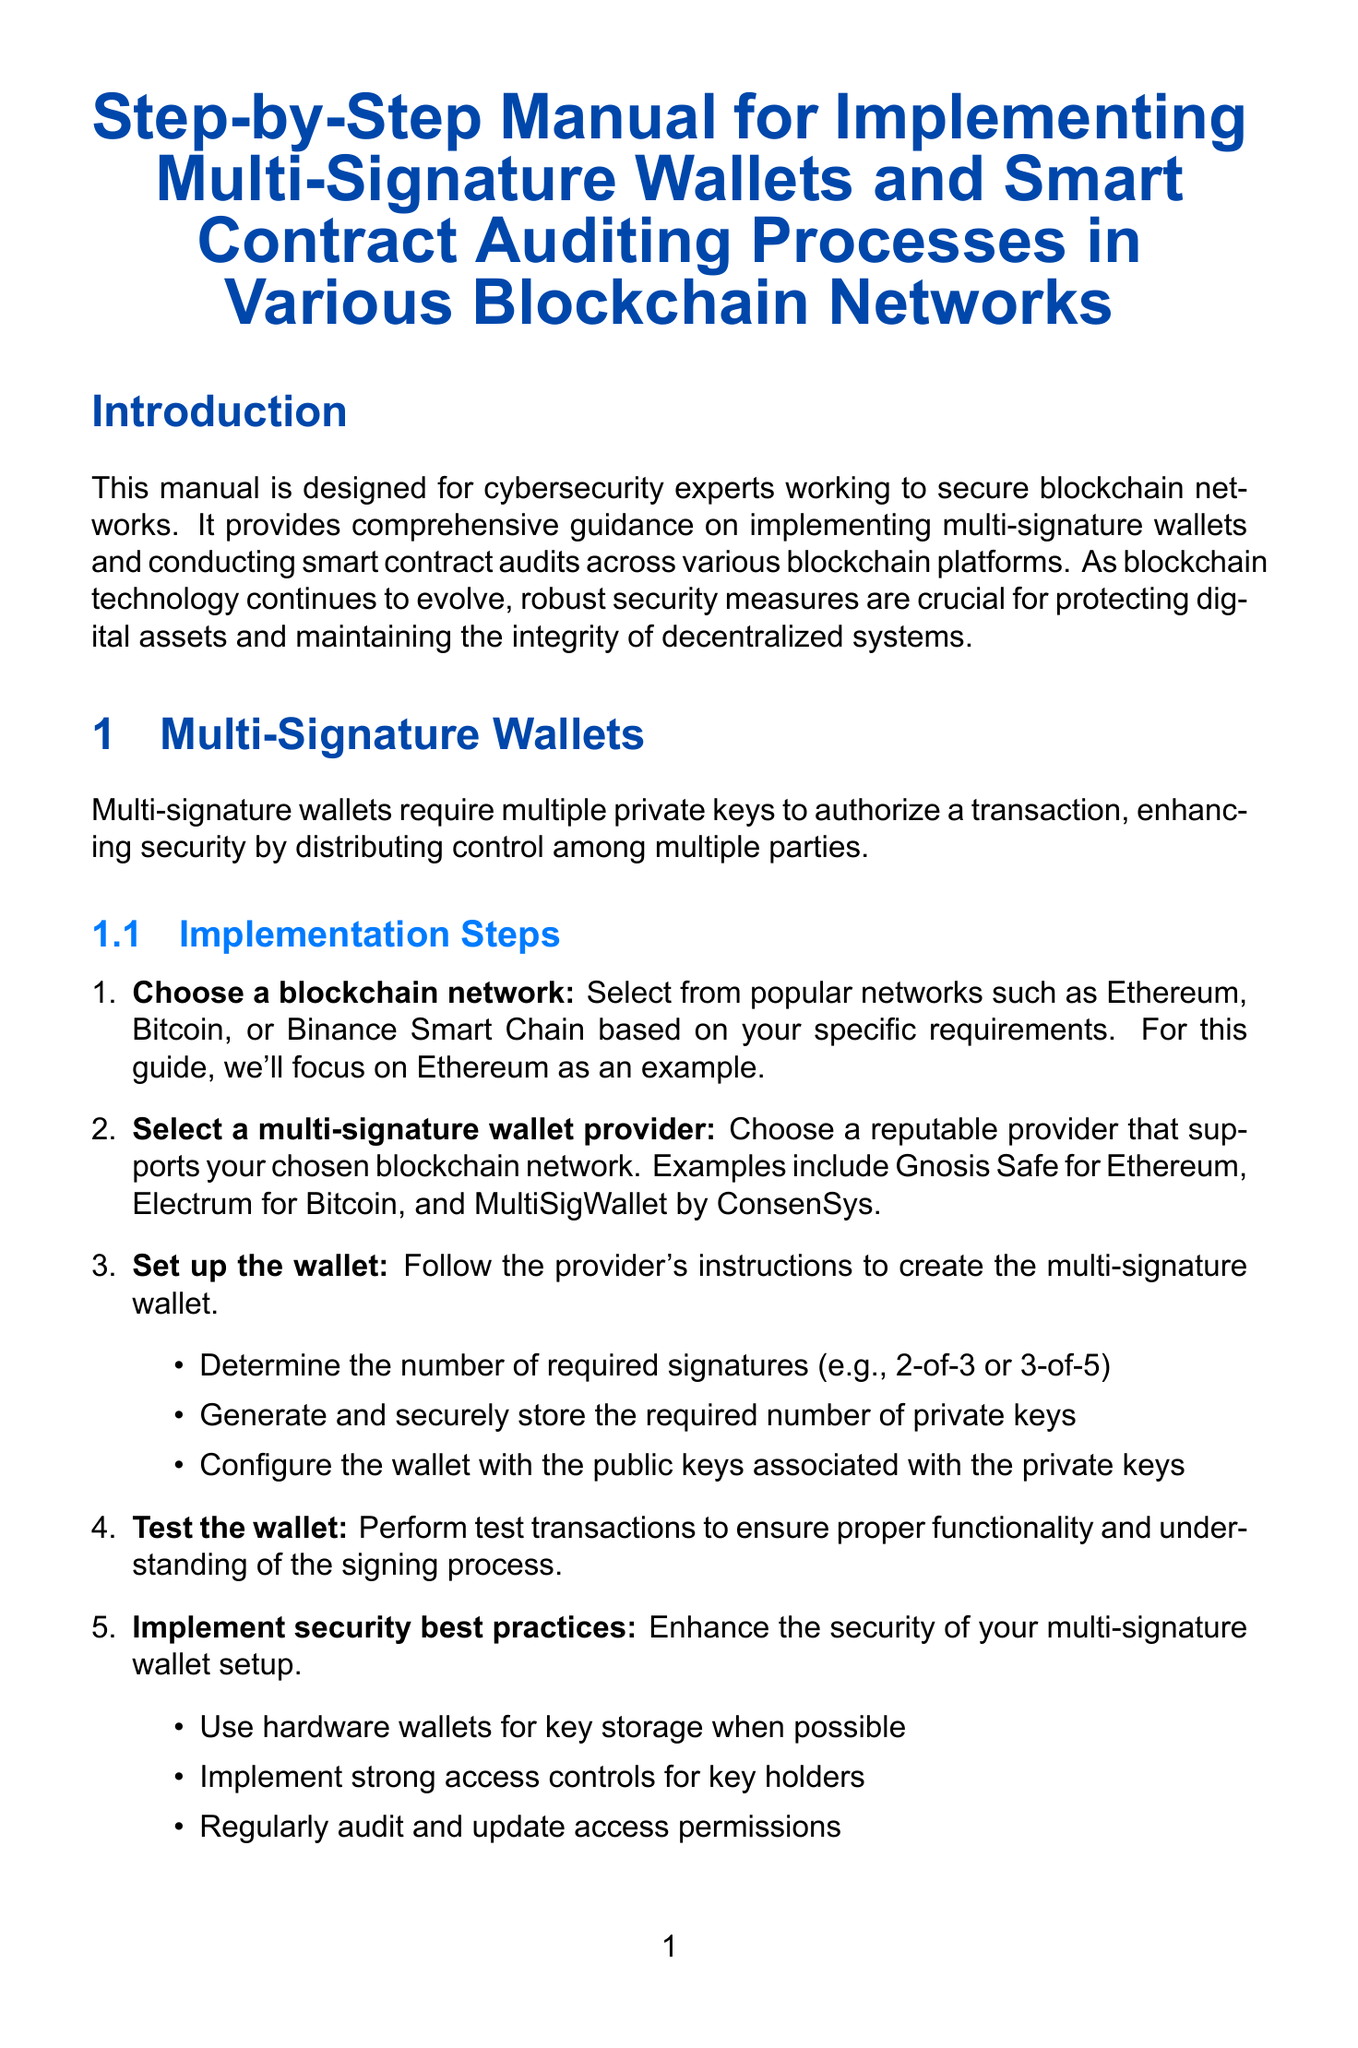What is the title of the manual? The title of the manual is provided in the introduction section, summarizing its purpose for cybersecurity experts.
Answer: Step-by-Step Manual for Implementing Multi-Signature Wallets and Smart Contract Auditing Processes in Various Blockchain Networks What blockchain network is primarily focused on in the implementation steps? The implementation steps specifically mention a blockchain network as an example for guidance.
Answer: Ethereum Name one multi-signature wallet provider for Ethereum. The document lists various providers for multi-signature wallets as part of the implementation steps.
Answer: Gnosis Safe What stage follows the preparation in the smart contract auditing process? The stages of the smart contract auditing process are listed sequentially in the manual.
Answer: Static Analysis What is one best practice for smart contract auditing? Best practices are provided to enhance the security of smart contracts, emphasizing established methods.
Answer: Use established libraries like OpenZeppelin for common functionalities How many required signatures are suggested in the wallet setup example? The document gives examples of required signatures for setting up a multi-signature wallet depending on various configurations.
Answer: 2-of-3 or 3-of-5 What type of analysis involves deploying a smart contract to a test network? The stages of the auditing process include descriptions of different analyses involved with smart contracts.
Answer: Dynamic Analysis What is the purpose of the report generated after auditing? The report generation section outlines the components that should be included after completing the auditing process.
Answer: Executive summary Name one tool mentioned for Ethereum smart contracts. Tools specific to Ethereum smart contracts are outlined in the blockchain-specific considerations section.
Answer: Truffle Suite 